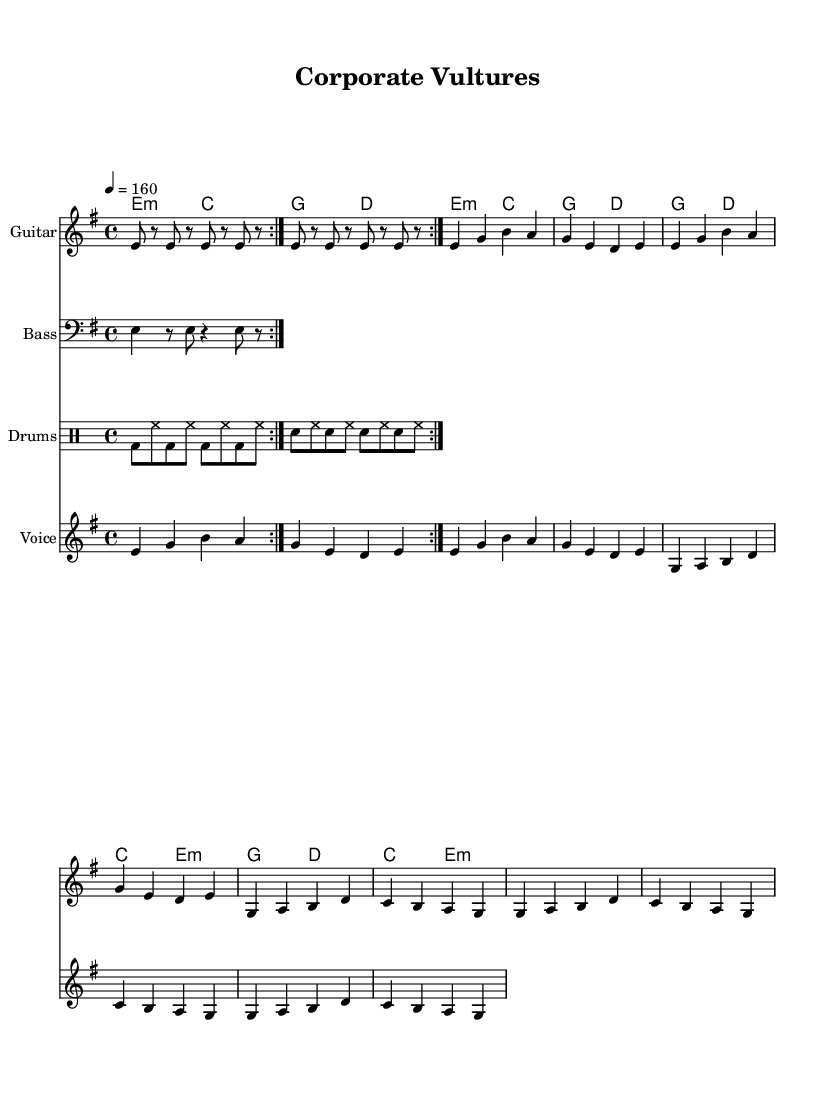What is the key signature of this music? The key signature is E minor, which has one sharp (F#). This can be identified at the beginning of the sheet music where the key signature is explicitly indicated before the staff.
Answer: E minor What is the time signature of this music? The time signature is 4/4, illustrated as a fraction at the beginning of the sheet music. This indicates there are four beats in each measure, and each quarter note receives one beat.
Answer: 4/4 What is the tempo marking of this music? The tempo marking is 160, which is indicated numerically in quarter notes per minute. This implies that the composer intended the piece to be played at a brisk pace.
Answer: 160 How many measures are in the verse? The verse consists of 4 measures, which can be counted by visually identifying the vertical lines that separate the different measures in the staff.
Answer: 4 What lyrical theme does the chorus convey? The chorus expresses the theme of commodification and cultural preservation, as indicated by the lyrics that reference corporate influences on history and culture. This thematic element is central to punk rock’s critique of societal norms.
Answer: Commodification What instrument plays the main riff in this piece? The guitar plays the main riff, as indicated by the staff labeled "Guitar" which shows the notes being played in the guitar part.
Answer: Guitar What musical elements signify its punk rock characteristics? The song features fast tempos, simple chord progressions, and politically charged lyrics, all typical of punk rock music, illustrating a rebellious spirit and directness in its message.
Answer: Fast tempos, simple chords, politically charged lyrics 